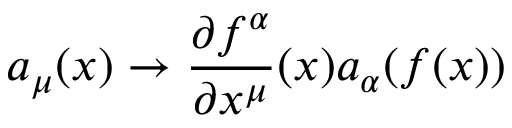<formula> <loc_0><loc_0><loc_500><loc_500>a _ { \mu } ( x ) \to \frac { \partial f ^ { \alpha } } { \partial x ^ { \mu } } ( x ) a _ { \alpha } ( f ( x ) )</formula> 